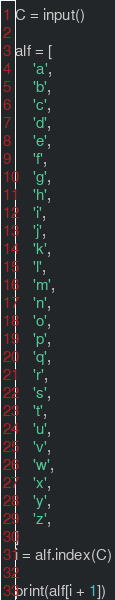Convert code to text. <code><loc_0><loc_0><loc_500><loc_500><_Python_>C = input()

alf = [
    'a',
    'b',
    'c',
    'd',
    'e',
    'f',
    'g',
    'h',
    'i',
    'j',
    'k',
    'l',
    'm',
    'n',
    'o',
    'p',
    'q',
    'r',
    's',
    't',
    'u',
    'v',
    'w',
    'x',
    'y',
    'z',
]
i = alf.index(C)

print(alf[i + 1])
</code> 